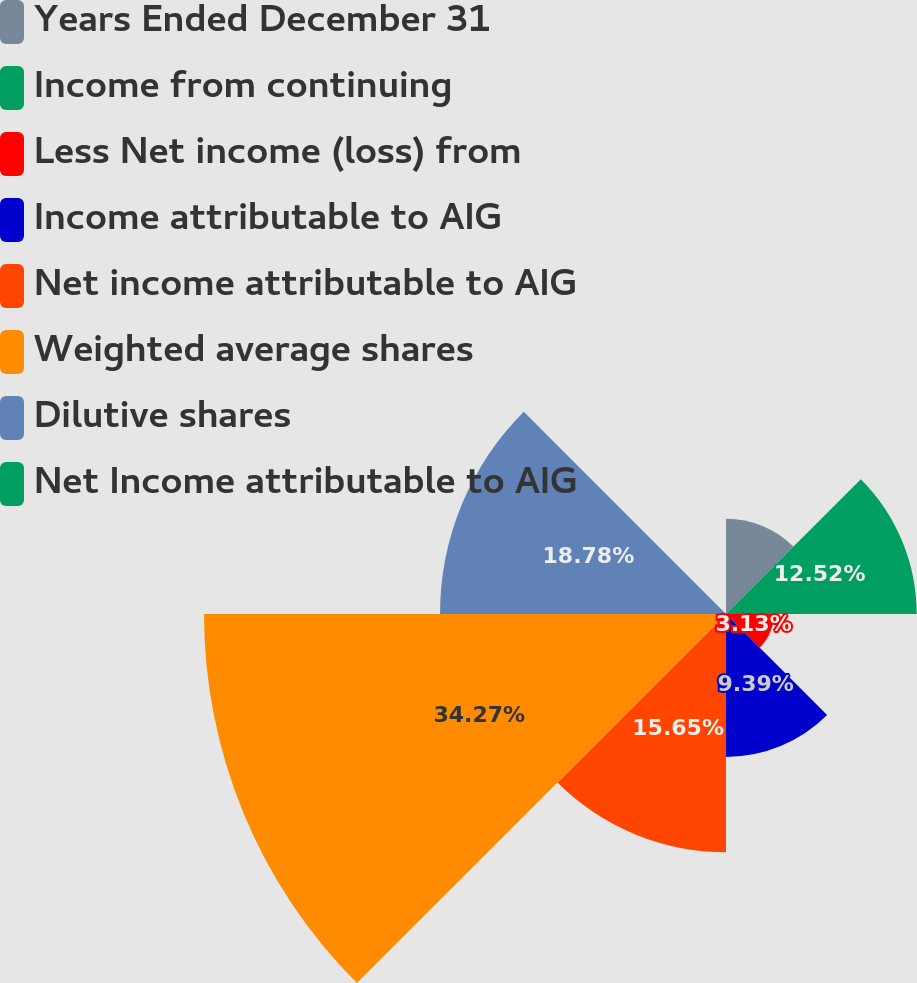<chart> <loc_0><loc_0><loc_500><loc_500><pie_chart><fcel>Years Ended December 31<fcel>Income from continuing<fcel>Less Net income (loss) from<fcel>Income attributable to AIG<fcel>Net income attributable to AIG<fcel>Weighted average shares<fcel>Dilutive shares<fcel>Net Income attributable to AIG<nl><fcel>6.26%<fcel>12.52%<fcel>3.13%<fcel>9.39%<fcel>15.65%<fcel>34.28%<fcel>18.78%<fcel>0.0%<nl></chart> 